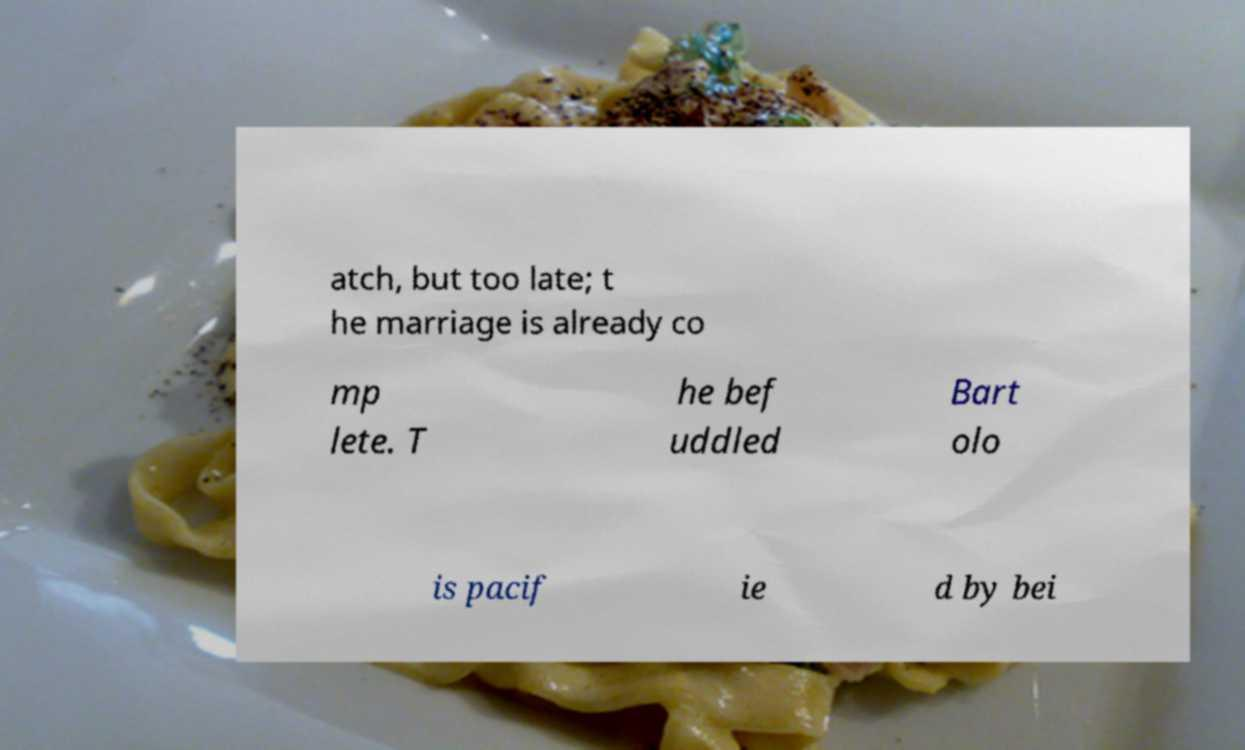For documentation purposes, I need the text within this image transcribed. Could you provide that? atch, but too late; t he marriage is already co mp lete. T he bef uddled Bart olo is pacif ie d by bei 